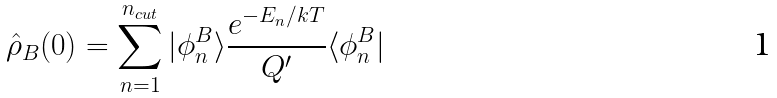Convert formula to latex. <formula><loc_0><loc_0><loc_500><loc_500>\hat { \rho } _ { B } ( 0 ) = \sum _ { n = 1 } ^ { n _ { c u t } } | \phi _ { n } ^ { B } \rangle \frac { e ^ { - E _ { n } / k T } } { Q ^ { \prime } } \langle \phi _ { n } ^ { B } |</formula> 